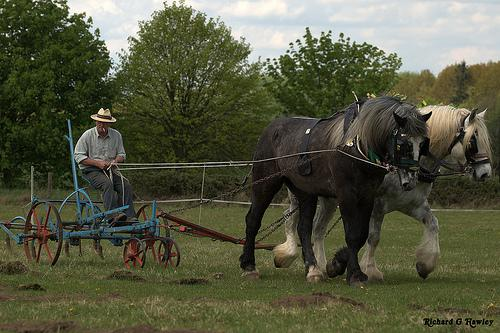Question: how is the car being pulled?
Choices:
A. Elephant.
B. Bull.
C. Horse.
D. Donkey.
Answer with the letter. Answer: C Question: who is sitting in the cart?
Choices:
A. Boy.
B. Farmer.
C. Girl.
D. Woman.
Answer with the letter. Answer: B Question: why are horses being used?
Choices:
A. Work animals.
B. Performing.
C. Training.
D. Racing.
Answer with the letter. Answer: A Question: what is on the man's head?
Choices:
A. Helmet.
B. Bandana.
C. Sunglasses.
D. Hat.
Answer with the letter. Answer: D Question: where are the animals?
Choices:
A. Zoo.
B. Farm.
C. Cage.
D. Field.
Answer with the letter. Answer: B Question: who took the photo?
Choices:
A. Richard G. Rowley.
B. Ansel Adams.
C. Annie Leibovitz.
D. Bruce Weber.
Answer with the letter. Answer: A 